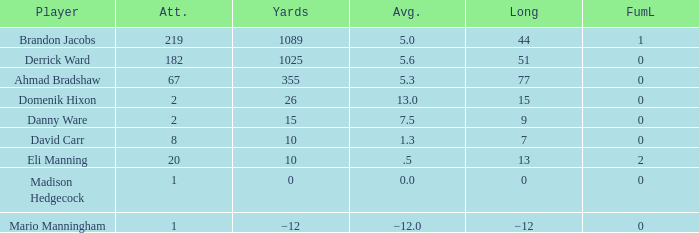What is domenik hixon's mean rush? 13.0. 